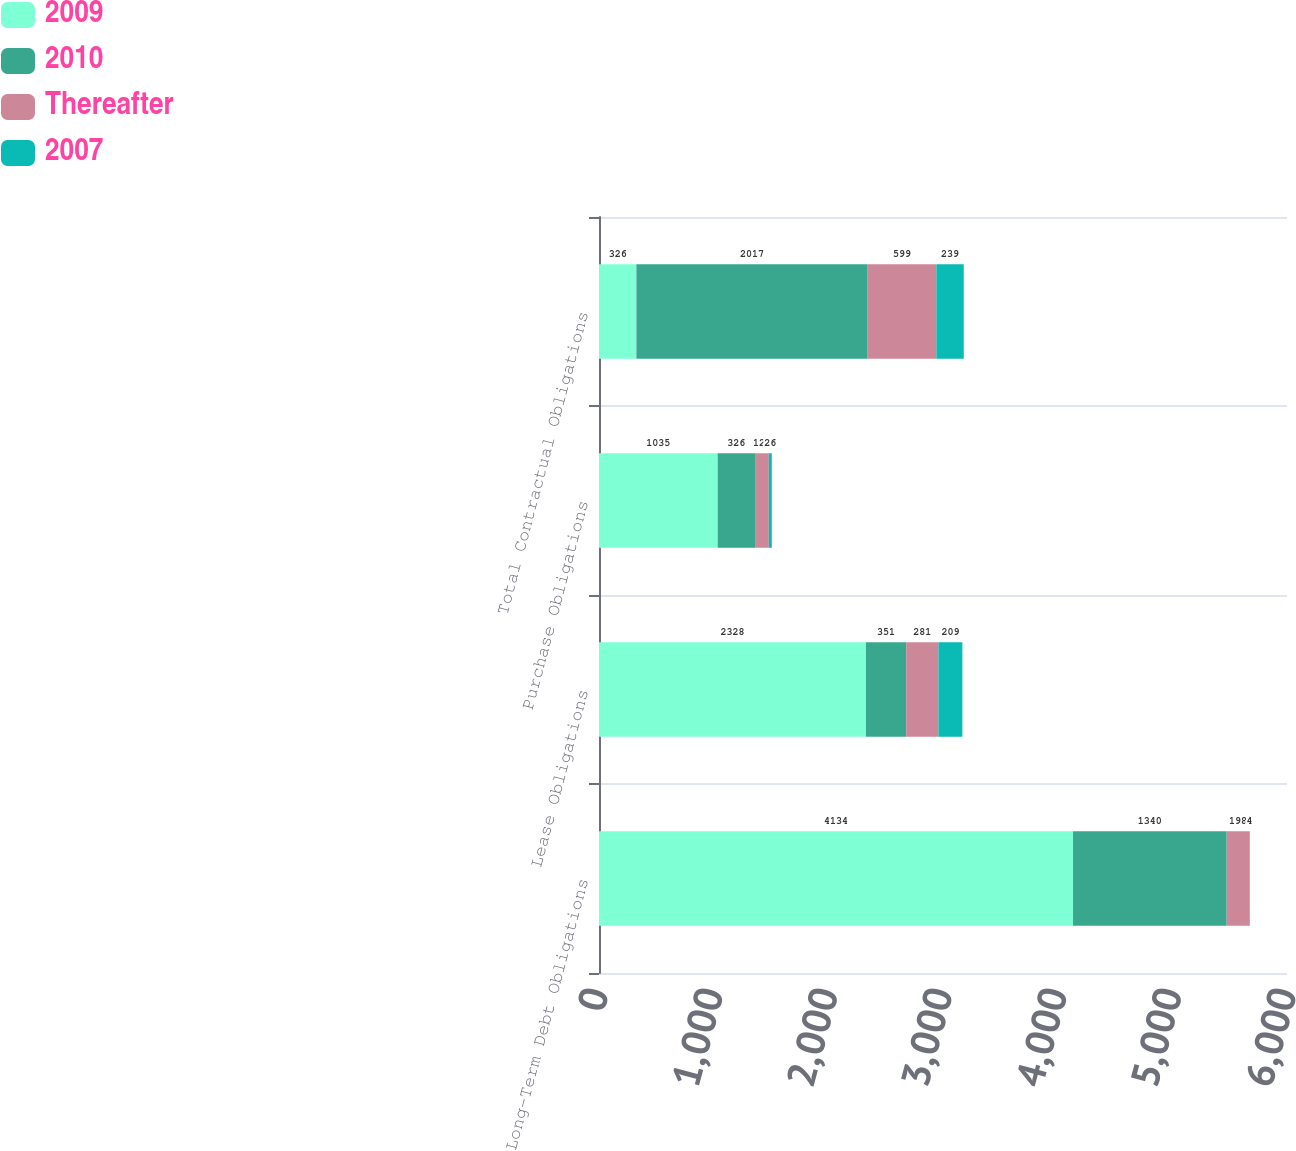Convert chart to OTSL. <chart><loc_0><loc_0><loc_500><loc_500><stacked_bar_chart><ecel><fcel>Long-Term Debt Obligations<fcel>Lease Obligations<fcel>Purchase Obligations<fcel>Total Contractual Obligations<nl><fcel>2009<fcel>4134<fcel>2328<fcel>1035<fcel>326<nl><fcel>2010<fcel>1340<fcel>351<fcel>326<fcel>2017<nl><fcel>Thereafter<fcel>198<fcel>281<fcel>120<fcel>599<nl><fcel>2007<fcel>4<fcel>209<fcel>26<fcel>239<nl></chart> 